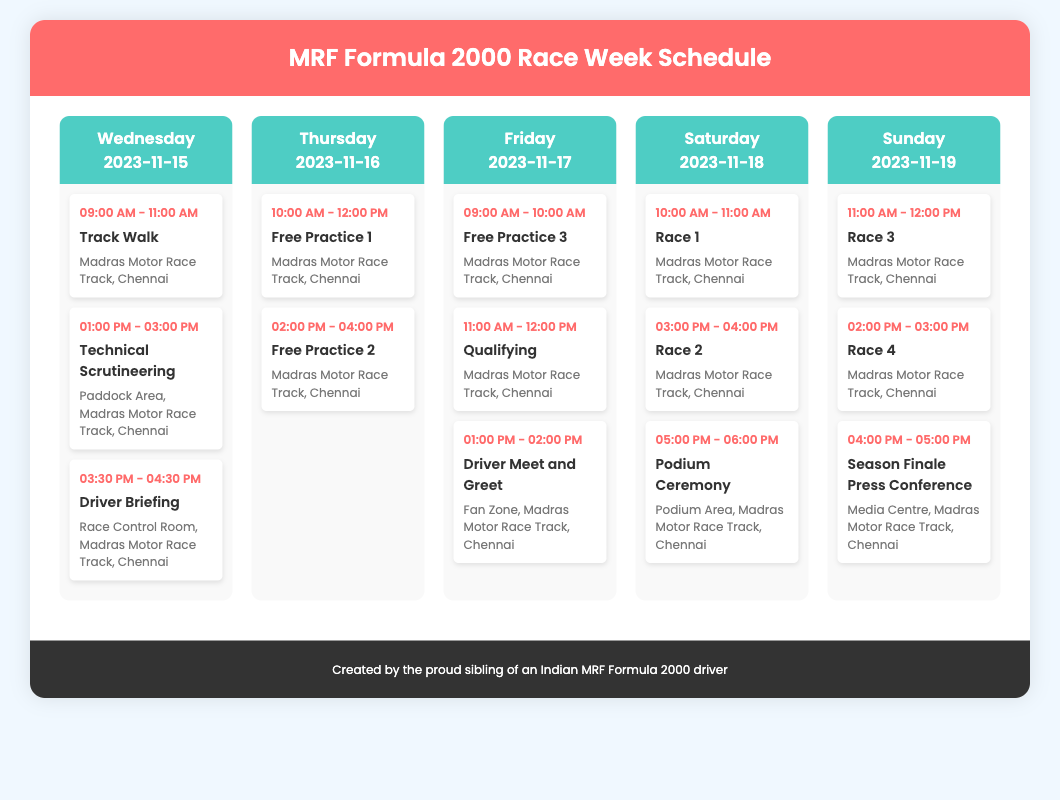What is the first event of the race week? The first event listed is the Track Walk on Wednesday, 2023-11-15, from 09:00 AM to 11:00 AM.
Answer: Track Walk What is the location for all the events during race week? All events are held at the Madras Motor Race Track in Chennai, which is specified for each session.
Answer: Madras Motor Race Track, Chennai How many qualifying sessions are scheduled during the week? Only one qualifying session is mentioned, occurring on Friday.
Answer: 1 What time does Race 1 take place? The specified time for Race 1 on Saturday is from 10:00 AM to 11:00 AM.
Answer: 10:00 AM - 11:00 AM What is the last event of the race week? The final event scheduled is the Season Finale Press Conference on Sunday at 04:00 PM.
Answer: Season Finale Press Conference How many races will take place during the weekend? There are four race sessions mentioned in total, two on Saturday and two on Sunday.
Answer: 4 What is the time for the Driver Meet and Greet? This event is scheduled for Friday from 01:00 PM to 02:00 PM.
Answer: 01:00 PM - 02:00 PM When does the Technical Scrutineering happen? The Technical Scrutineering is on Wednesday from 01:00 PM to 03:00 PM.
Answer: 01:00 PM - 03:00 PM 